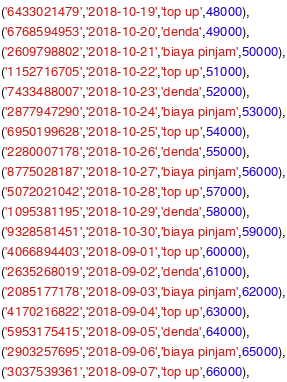Convert code to text. <code><loc_0><loc_0><loc_500><loc_500><_SQL_>('6433021479','2018-10-19','top up',48000),
('6768594953','2018-10-20','denda',49000),
('2609798802','2018-10-21','biaya pinjam',50000),
('1152716705','2018-10-22','top up',51000),
('7433488007','2018-10-23','denda',52000),
('2877947290','2018-10-24','biaya pinjam',53000),
('6950199628','2018-10-25','top up',54000),
('2280007178','2018-10-26','denda',55000),
('8775028187','2018-10-27','biaya pinjam',56000),
('5072021042','2018-10-28','top up',57000),
('1095381195','2018-10-29','denda',58000),
('9328581451','2018-10-30','biaya pinjam',59000),
('4066894403','2018-09-01','top up',60000),
('2635268019','2018-09-02','denda',61000),
('2085177178','2018-09-03','biaya pinjam',62000),
('4170216822','2018-09-04','top up',63000),
('5953175415','2018-09-05','denda',64000),
('2903257695','2018-09-06','biaya pinjam',65000),
('3037539361','2018-09-07','top up',66000),</code> 